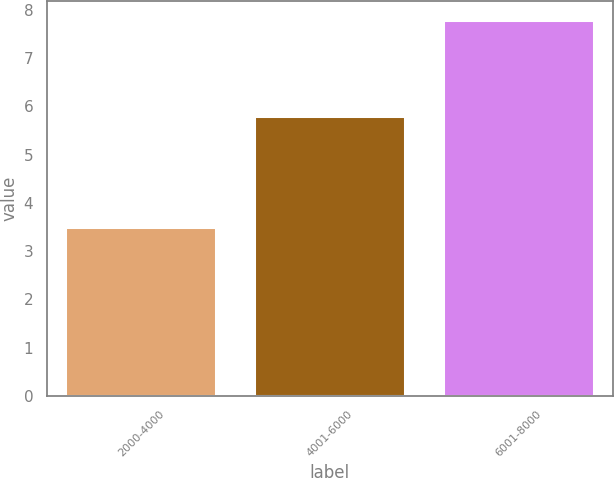<chart> <loc_0><loc_0><loc_500><loc_500><bar_chart><fcel>2000-4000<fcel>4001-6000<fcel>6001-8000<nl><fcel>3.5<fcel>5.8<fcel>7.8<nl></chart> 